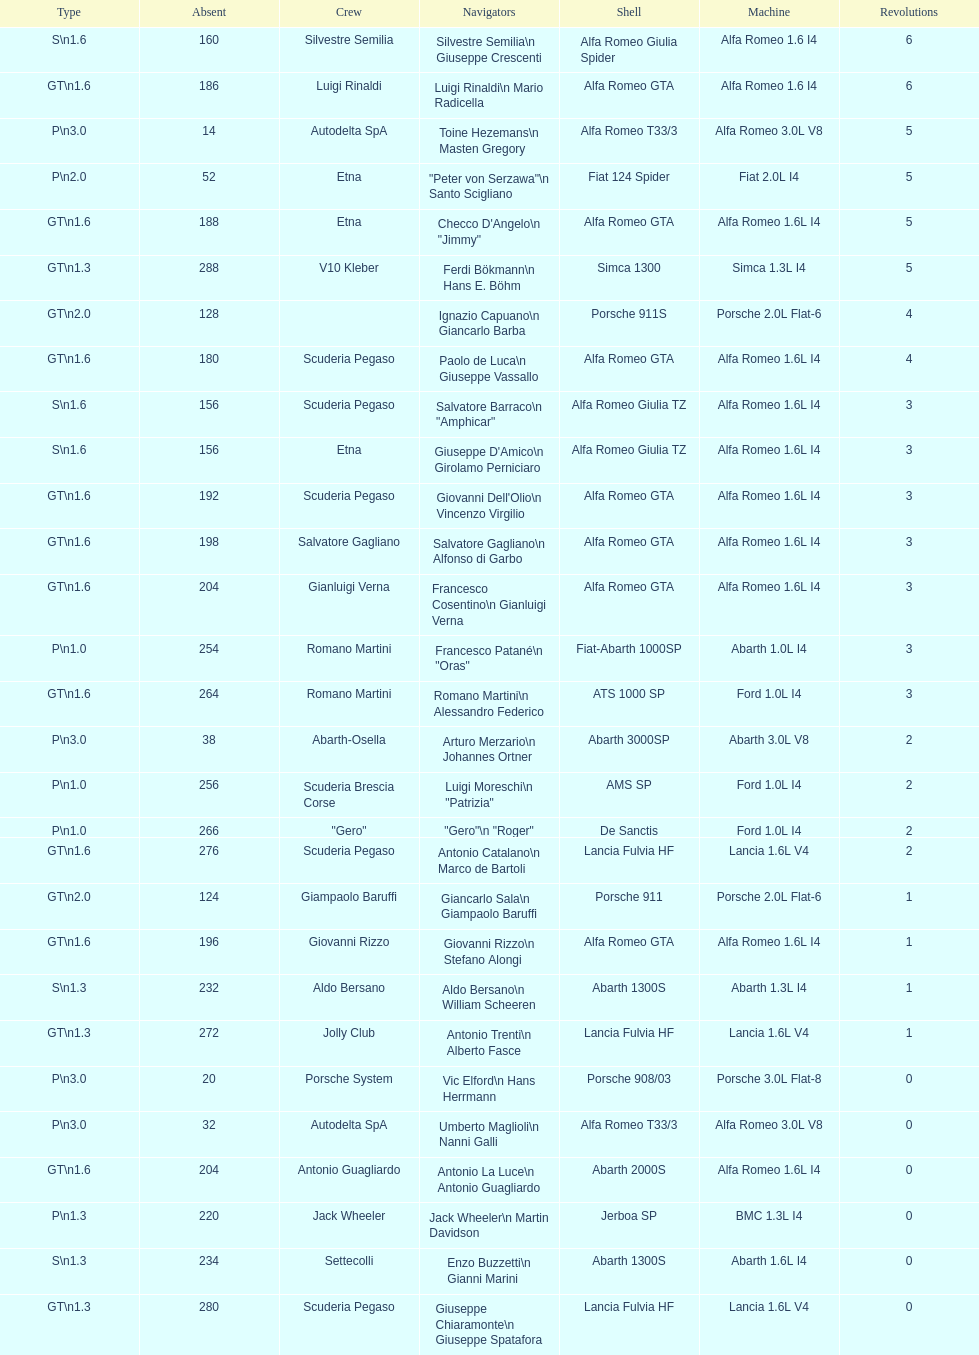How many drivers are from italy? 48. 